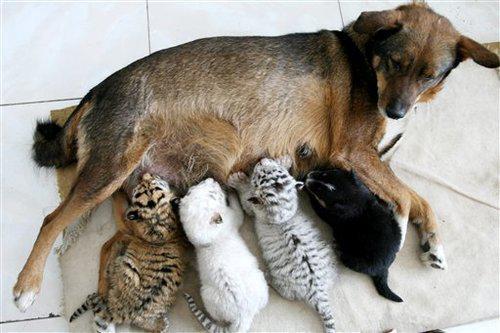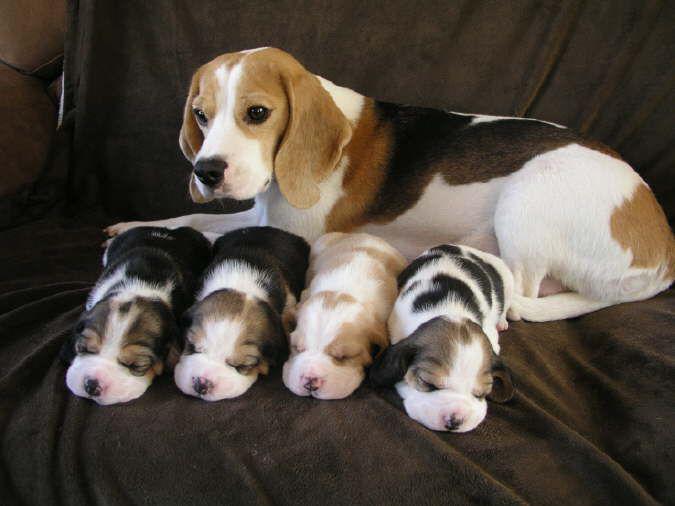The first image is the image on the left, the second image is the image on the right. Considering the images on both sides, is "Two dogs pose together in the image on the left." valid? Answer yes or no. No. The first image is the image on the left, the second image is the image on the right. Considering the images on both sides, is "The left image contains exactly two puppies." valid? Answer yes or no. No. 